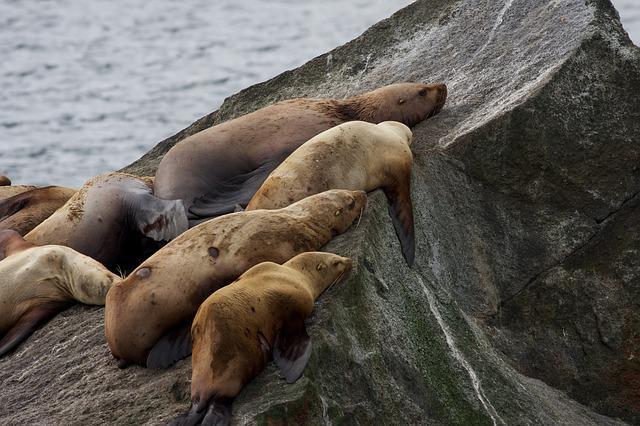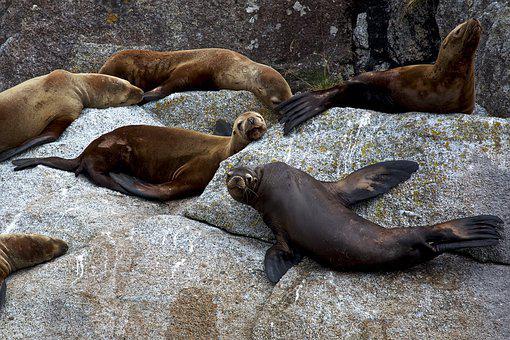The first image is the image on the left, the second image is the image on the right. Given the left and right images, does the statement "An image shows a mass of seals lying on a structure made of wooden planks." hold true? Answer yes or no. No. The first image is the image on the left, the second image is the image on the right. Considering the images on both sides, is "There are less than ten sea mammals sunning in the image on the right." valid? Answer yes or no. Yes. 